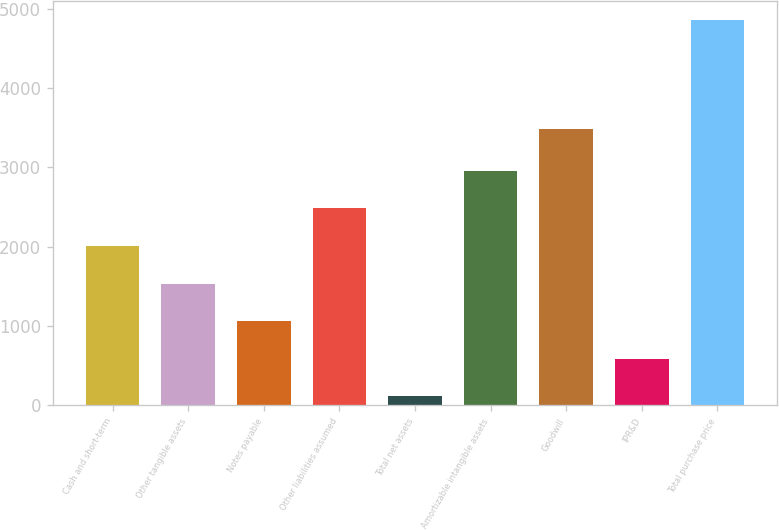Convert chart to OTSL. <chart><loc_0><loc_0><loc_500><loc_500><bar_chart><fcel>Cash and short-term<fcel>Other tangible assets<fcel>Notes payable<fcel>Other liabilities assumed<fcel>Total net assets<fcel>Amortizable intangible assets<fcel>Goodwill<fcel>IPR&D<fcel>Total purchase price<nl><fcel>2010<fcel>1536<fcel>1062<fcel>2484<fcel>114<fcel>2958<fcel>3480<fcel>588<fcel>4854<nl></chart> 